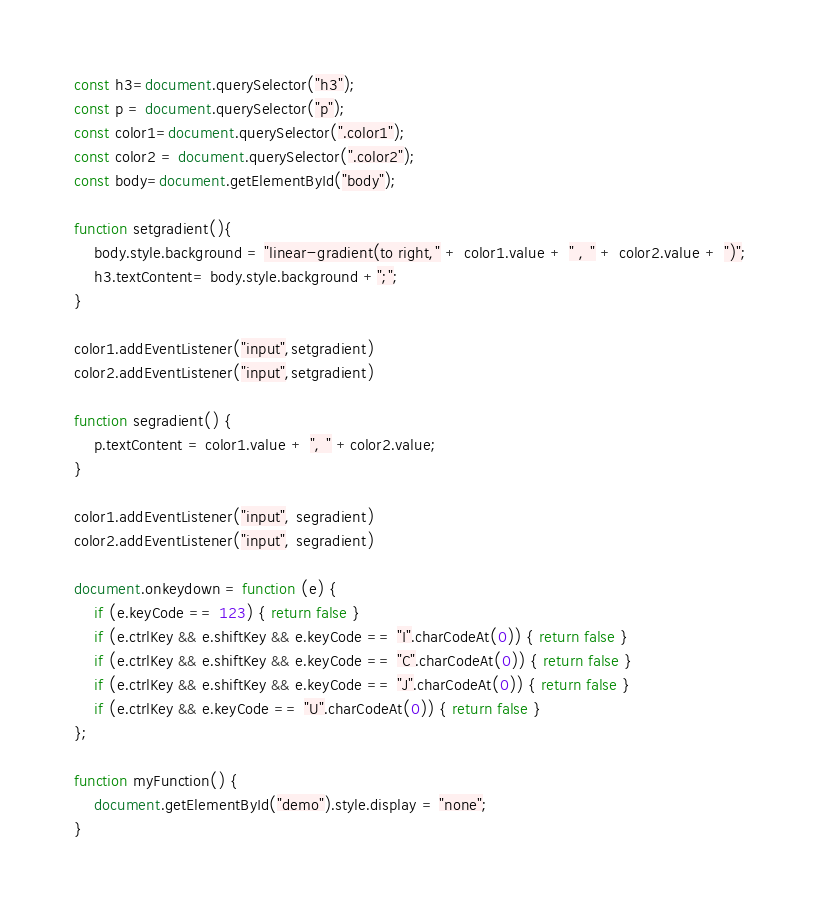<code> <loc_0><loc_0><loc_500><loc_500><_JavaScript_>const h3=document.querySelector("h3");
const p = document.querySelector("p");
const color1=document.querySelector(".color1");
const color2 = document.querySelector(".color2");
const body=document.getElementById("body");

function setgradient(){
    body.style.background = "linear-gradient(to right," + color1.value + " , " + color2.value + ")";
    h3.textContent= body.style.background +";"; 
}

color1.addEventListener("input",setgradient)
color2.addEventListener("input",setgradient)

function segradient() {
    p.textContent = color1.value + ", " +color2.value;
}

color1.addEventListener("input", segradient)
color2.addEventListener("input", segradient)

document.onkeydown = function (e) {
    if (e.keyCode == 123) { return false }
    if (e.ctrlKey && e.shiftKey && e.keyCode == "I".charCodeAt(0)) { return false }
    if (e.ctrlKey && e.shiftKey && e.keyCode == "C".charCodeAt(0)) { return false }
    if (e.ctrlKey && e.shiftKey && e.keyCode == "J".charCodeAt(0)) { return false }
    if (e.ctrlKey && e.keyCode == "U".charCodeAt(0)) { return false }
};

function myFunction() {
    document.getElementById("demo").style.display = "none";
}</code> 